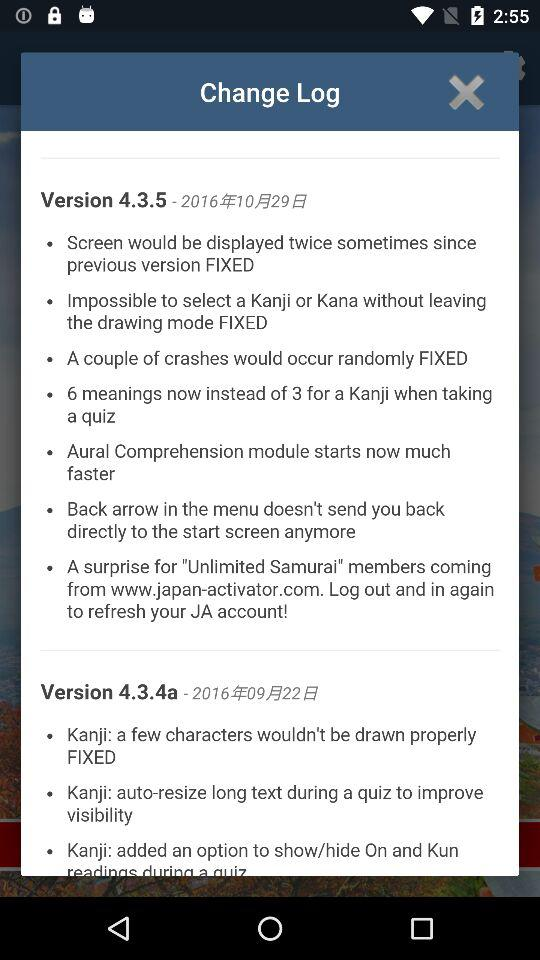What are the new features in Version 4.3.5? The new features are "Screen would be displayed twice sometimes since previous version FIXED", "Impossible to select a Kanji or Kana without leaving the drawing mode FIXED", "A couple of crashes would occur randomly FIXED", "6 meanings now instead of 3 for a Kanji when taking a quiz", "Aural Comprehension module starts now much faster", "Back arrow in the menu doesn't send you back directly to the start screen anymore" and "A surprise for "Unlimited Samurai" members coming from www.japan-activator.com. Log out and in again to refresh your JA account!". 